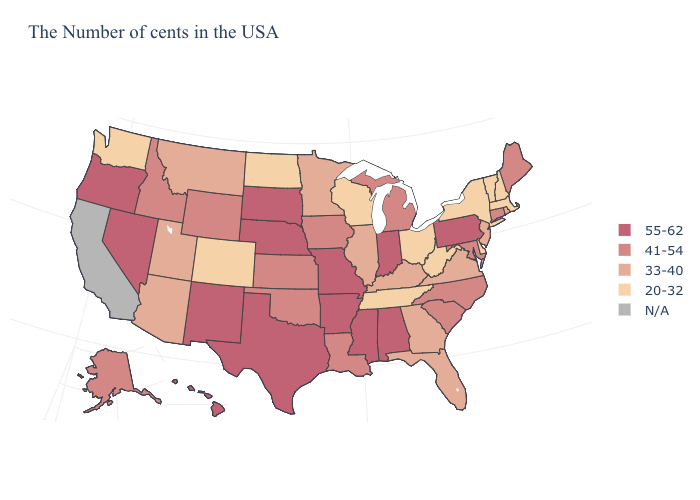Which states have the lowest value in the USA?
Answer briefly. Massachusetts, New Hampshire, Vermont, New York, Delaware, West Virginia, Ohio, Tennessee, Wisconsin, North Dakota, Colorado, Washington. What is the value of Utah?
Be succinct. 33-40. Name the states that have a value in the range 33-40?
Concise answer only. Rhode Island, New Jersey, Virginia, Florida, Georgia, Kentucky, Illinois, Minnesota, Utah, Montana, Arizona. Does New York have the lowest value in the Northeast?
Quick response, please. Yes. What is the highest value in the USA?
Give a very brief answer. 55-62. What is the highest value in the MidWest ?
Quick response, please. 55-62. Among the states that border Kentucky , which have the highest value?
Keep it brief. Indiana, Missouri. Name the states that have a value in the range 33-40?
Quick response, please. Rhode Island, New Jersey, Virginia, Florida, Georgia, Kentucky, Illinois, Minnesota, Utah, Montana, Arizona. What is the value of Pennsylvania?
Short answer required. 55-62. Which states have the lowest value in the MidWest?
Be succinct. Ohio, Wisconsin, North Dakota. Which states have the lowest value in the USA?
Give a very brief answer. Massachusetts, New Hampshire, Vermont, New York, Delaware, West Virginia, Ohio, Tennessee, Wisconsin, North Dakota, Colorado, Washington. 